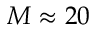<formula> <loc_0><loc_0><loc_500><loc_500>M \approx 2 0</formula> 